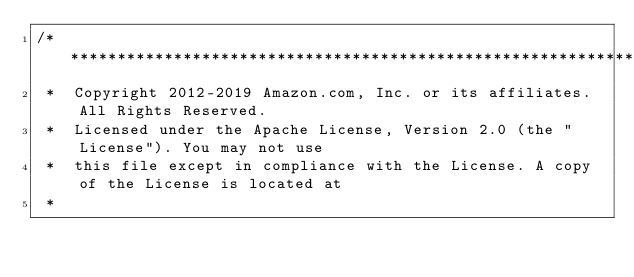Convert code to text. <code><loc_0><loc_0><loc_500><loc_500><_C#_>/*******************************************************************************
 *  Copyright 2012-2019 Amazon.com, Inc. or its affiliates. All Rights Reserved.
 *  Licensed under the Apache License, Version 2.0 (the "License"). You may not use
 *  this file except in compliance with the License. A copy of the License is located at
 *</code> 